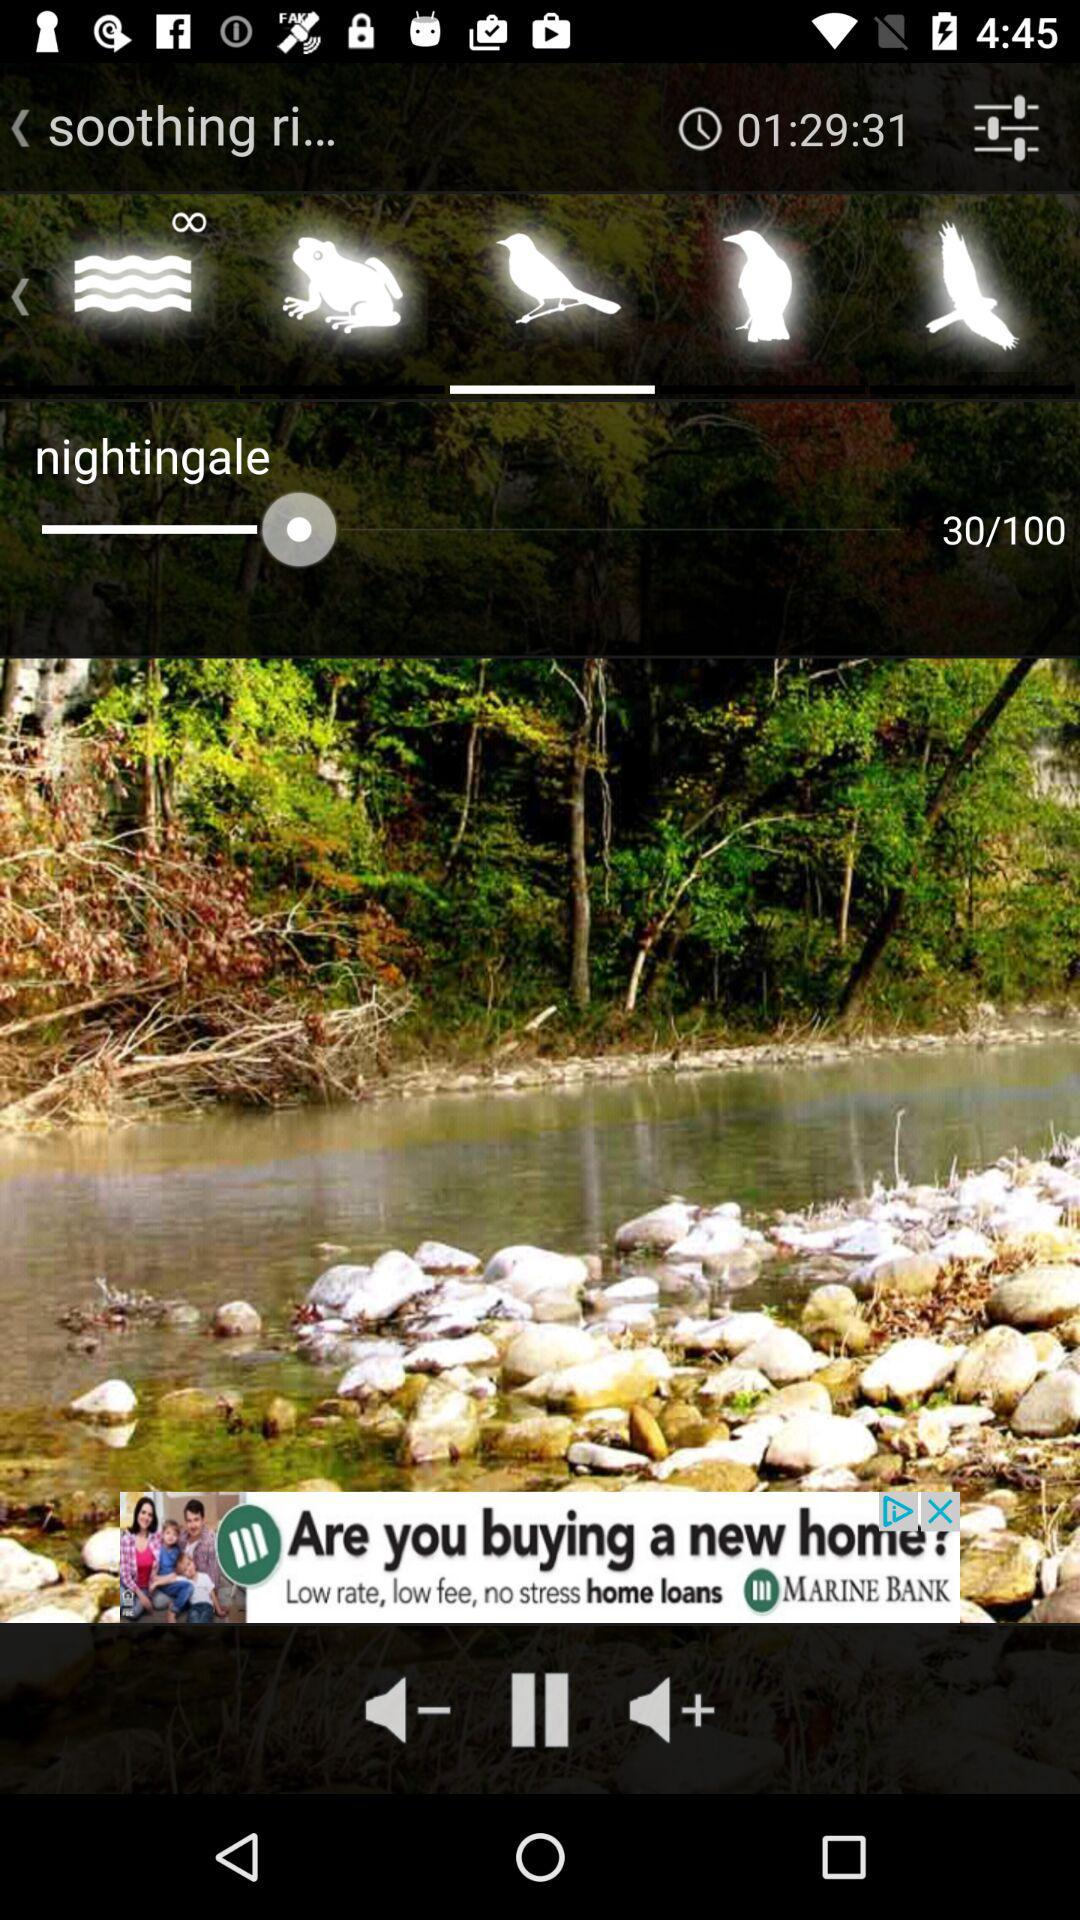How many total Nightingale ringtones are there?
When the provided information is insufficient, respond with <no answer>. <no answer> 